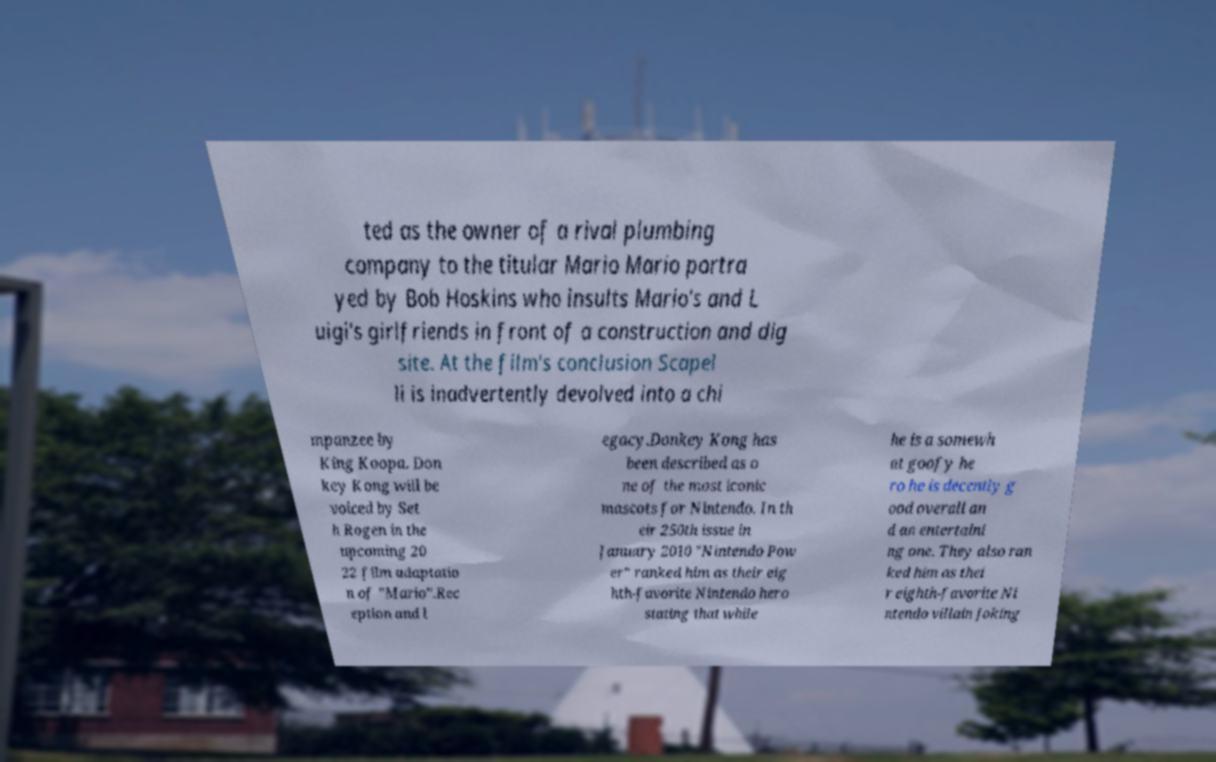What messages or text are displayed in this image? I need them in a readable, typed format. ted as the owner of a rival plumbing company to the titular Mario Mario portra yed by Bob Hoskins who insults Mario's and L uigi's girlfriends in front of a construction and dig site. At the film's conclusion Scapel li is inadvertently devolved into a chi mpanzee by King Koopa. Don key Kong will be voiced by Set h Rogen in the upcoming 20 22 film adaptatio n of "Mario".Rec eption and l egacy.Donkey Kong has been described as o ne of the most iconic mascots for Nintendo. In th eir 250th issue in January 2010 "Nintendo Pow er" ranked him as their eig hth-favorite Nintendo hero stating that while he is a somewh at goofy he ro he is decently g ood overall an d an entertaini ng one. They also ran ked him as thei r eighth-favorite Ni ntendo villain joking 